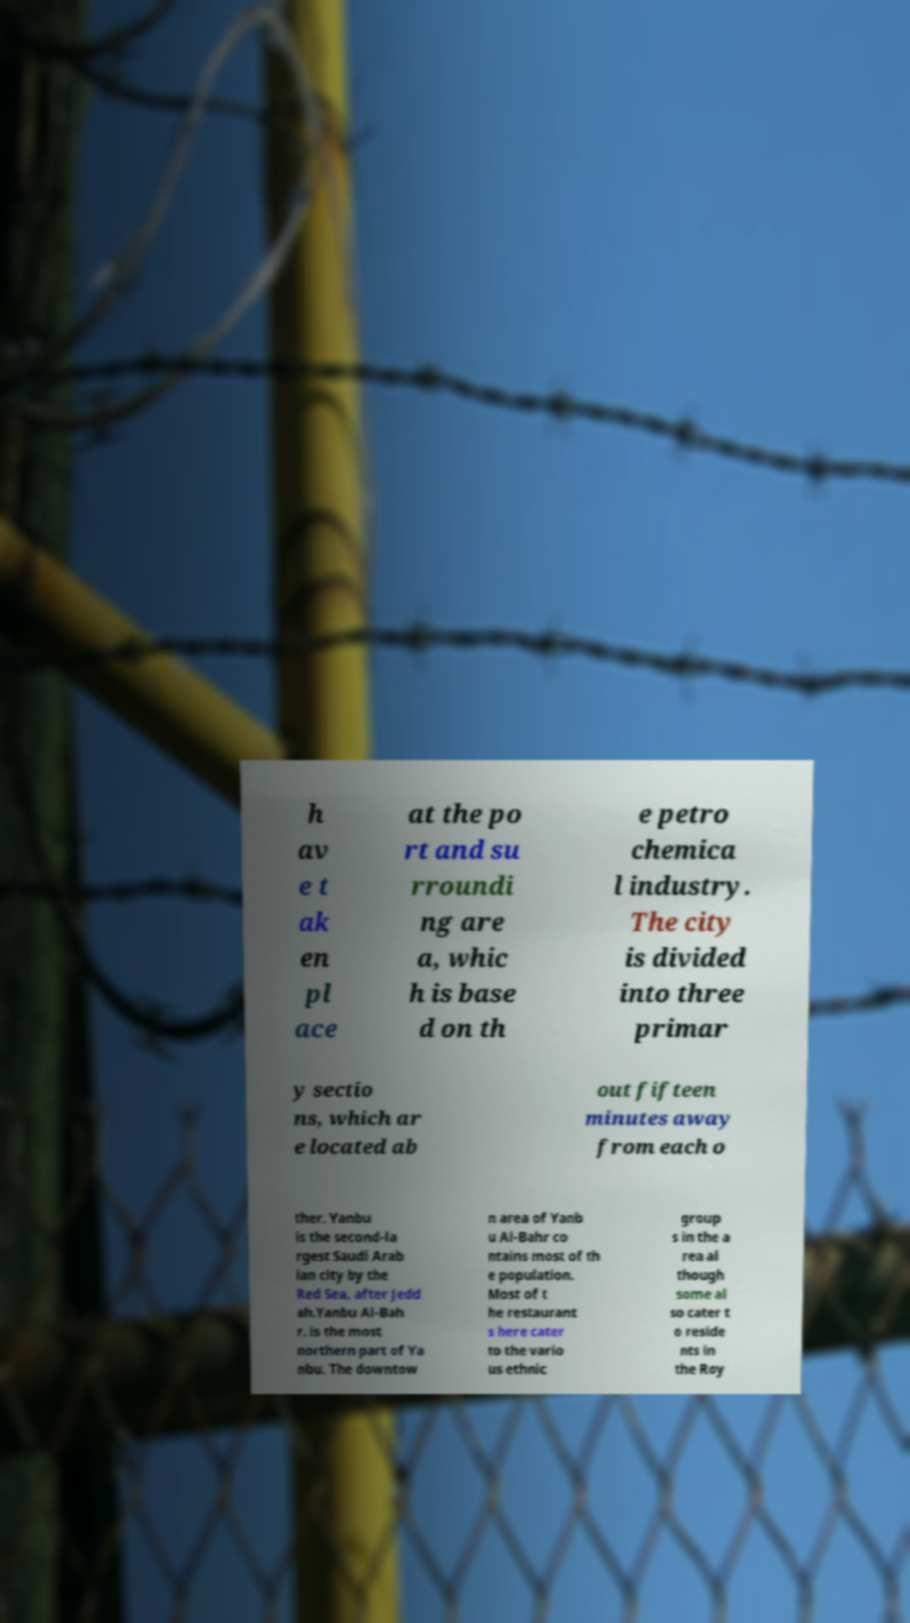Please read and relay the text visible in this image. What does it say? h av e t ak en pl ace at the po rt and su rroundi ng are a, whic h is base d on th e petro chemica l industry. The city is divided into three primar y sectio ns, which ar e located ab out fifteen minutes away from each o ther. Yanbu is the second-la rgest Saudi Arab ian city by the Red Sea, after Jedd ah.Yanbu Al-Bah r. is the most northern part of Ya nbu. The downtow n area of Yanb u Al-Bahr co ntains most of th e population. Most of t he restaurant s here cater to the vario us ethnic group s in the a rea al though some al so cater t o reside nts in the Roy 